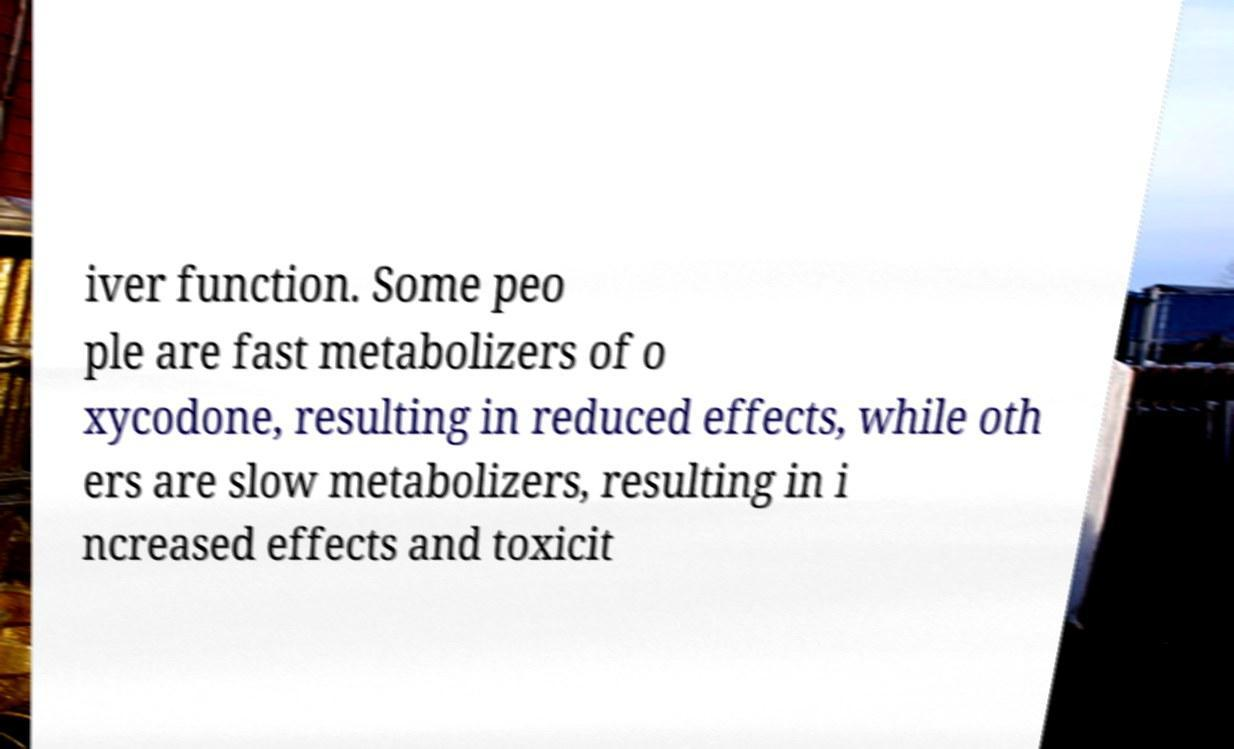Could you assist in decoding the text presented in this image and type it out clearly? iver function. Some peo ple are fast metabolizers of o xycodone, resulting in reduced effects, while oth ers are slow metabolizers, resulting in i ncreased effects and toxicit 